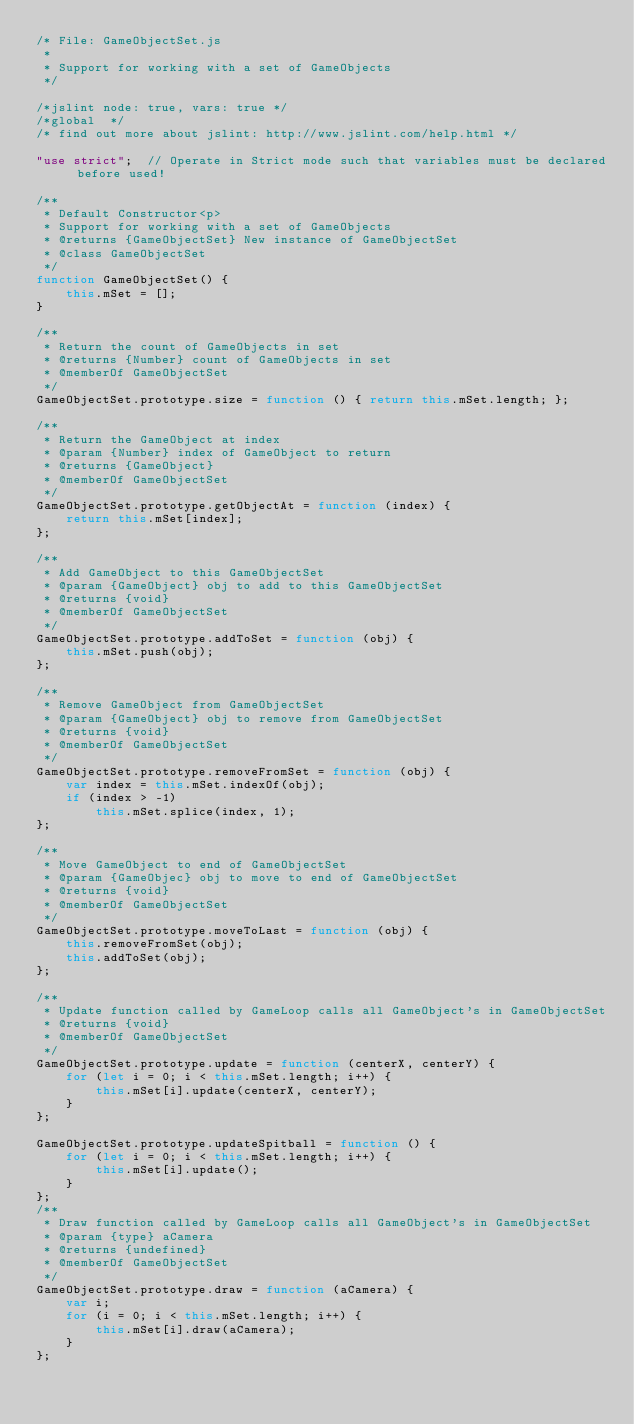Convert code to text. <code><loc_0><loc_0><loc_500><loc_500><_JavaScript_>/* File: GameObjectSet.js 
 *
 * Support for working with a set of GameObjects
 */

/*jslint node: true, vars: true */
/*global  */
/* find out more about jslint: http://www.jslint.com/help.html */

"use strict";  // Operate in Strict mode such that variables must be declared before used!

/**
 * Default Constructor<p>
 * Support for working with a set of GameObjects
 * @returns {GameObjectSet} New instance of GameObjectSet
 * @class GameObjectSet
 */
function GameObjectSet() {
    this.mSet = [];
}

/**
 * Return the count of GameObjects in set
 * @returns {Number} count of GameObjects in set
 * @memberOf GameObjectSet
 */
GameObjectSet.prototype.size = function () { return this.mSet.length; };

/**
 * Return the GameObject at index
 * @param {Number} index of GameObject to return
 * @returns {GameObject}
 * @memberOf GameObjectSet
 */
GameObjectSet.prototype.getObjectAt = function (index) {
    return this.mSet[index];
};

/**
 * Add GameObject to this GameObjectSet
 * @param {GameObject} obj to add to this GameObjectSet
 * @returns {void}
 * @memberOf GameObjectSet
 */
GameObjectSet.prototype.addToSet = function (obj) {
    this.mSet.push(obj);
};

/**
 * Remove GameObject from GameObjectSet
 * @param {GameObject} obj to remove from GameObjectSet
 * @returns {void}
 * @memberOf GameObjectSet
 */
GameObjectSet.prototype.removeFromSet = function (obj) {
    var index = this.mSet.indexOf(obj);
    if (index > -1)
        this.mSet.splice(index, 1);
};

/**
 * Move GameObject to end of GameObjectSet
 * @param {GameObjec} obj to move to end of GameObjectSet
 * @returns {void}
 * @memberOf GameObjectSet
 */
GameObjectSet.prototype.moveToLast = function (obj) {
    this.removeFromSet(obj);
    this.addToSet(obj);
};

/**
 * Update function called by GameLoop calls all GameObject's in GameObjectSet
 * @returns {void}
 * @memberOf GameObjectSet
 */
GameObjectSet.prototype.update = function (centerX, centerY) {
    for (let i = 0; i < this.mSet.length; i++) {
        this.mSet[i].update(centerX, centerY);
    }
};

GameObjectSet.prototype.updateSpitball = function () {
    for (let i = 0; i < this.mSet.length; i++) {
        this.mSet[i].update();
    }
};
/**
 * Draw function called by GameLoop calls all GameObject's in GameObjectSet
 * @param {type} aCamera
 * @returns {undefined}
 * @memberOf GameObjectSet
 */
GameObjectSet.prototype.draw = function (aCamera) {
    var i;
    for (i = 0; i < this.mSet.length; i++) {
        this.mSet[i].draw(aCamera);
    }
};
</code> 